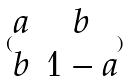<formula> <loc_0><loc_0><loc_500><loc_500>( \begin{matrix} a & b \\ b & 1 - a \end{matrix} )</formula> 